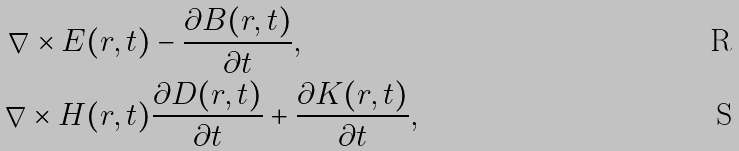Convert formula to latex. <formula><loc_0><loc_0><loc_500><loc_500>\nabla \times E ( r , t ) & - \frac { \partial B ( r , t ) } { \partial t } , \\ \nabla \times H ( r , t ) & \frac { \partial D ( r , t ) } { \partial t } + \frac { \partial K ( r , t ) } { \partial t } ,</formula> 